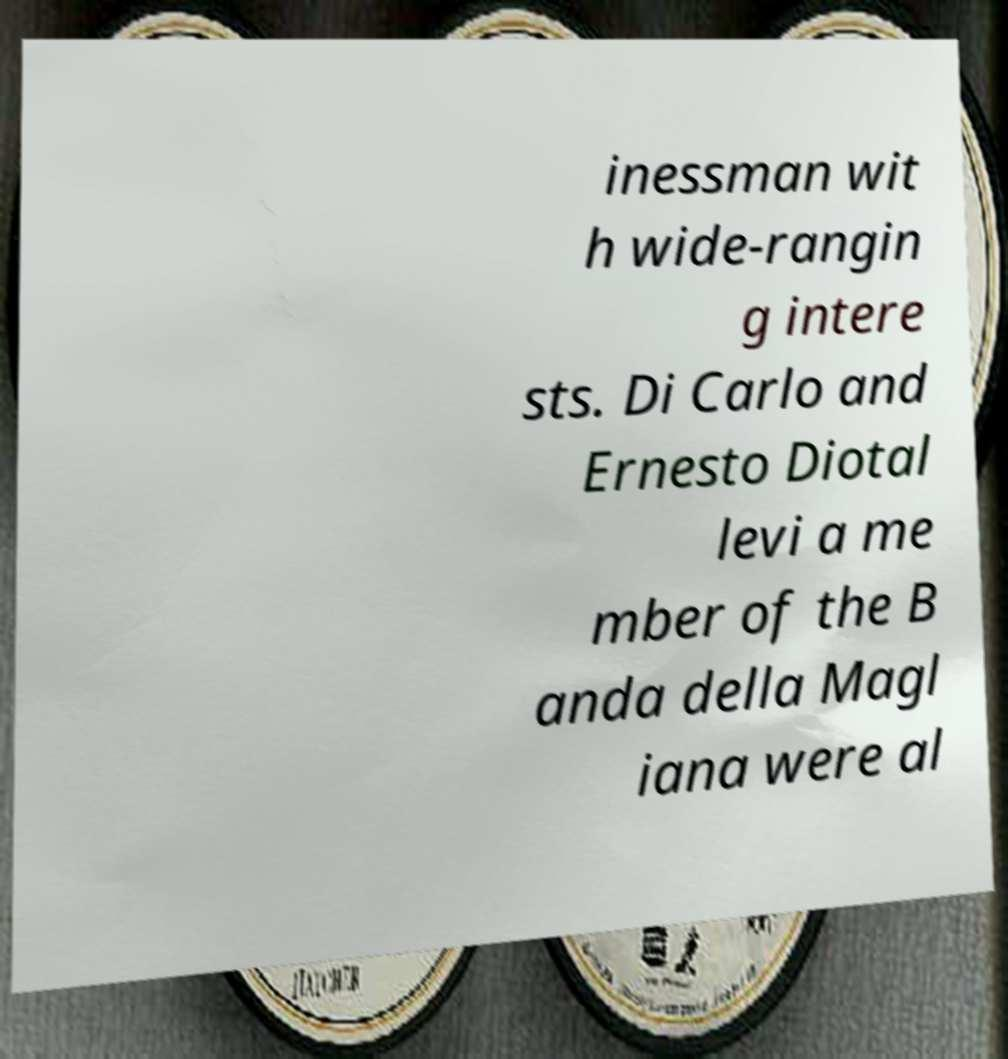I need the written content from this picture converted into text. Can you do that? inessman wit h wide-rangin g intere sts. Di Carlo and Ernesto Diotal levi a me mber of the B anda della Magl iana were al 